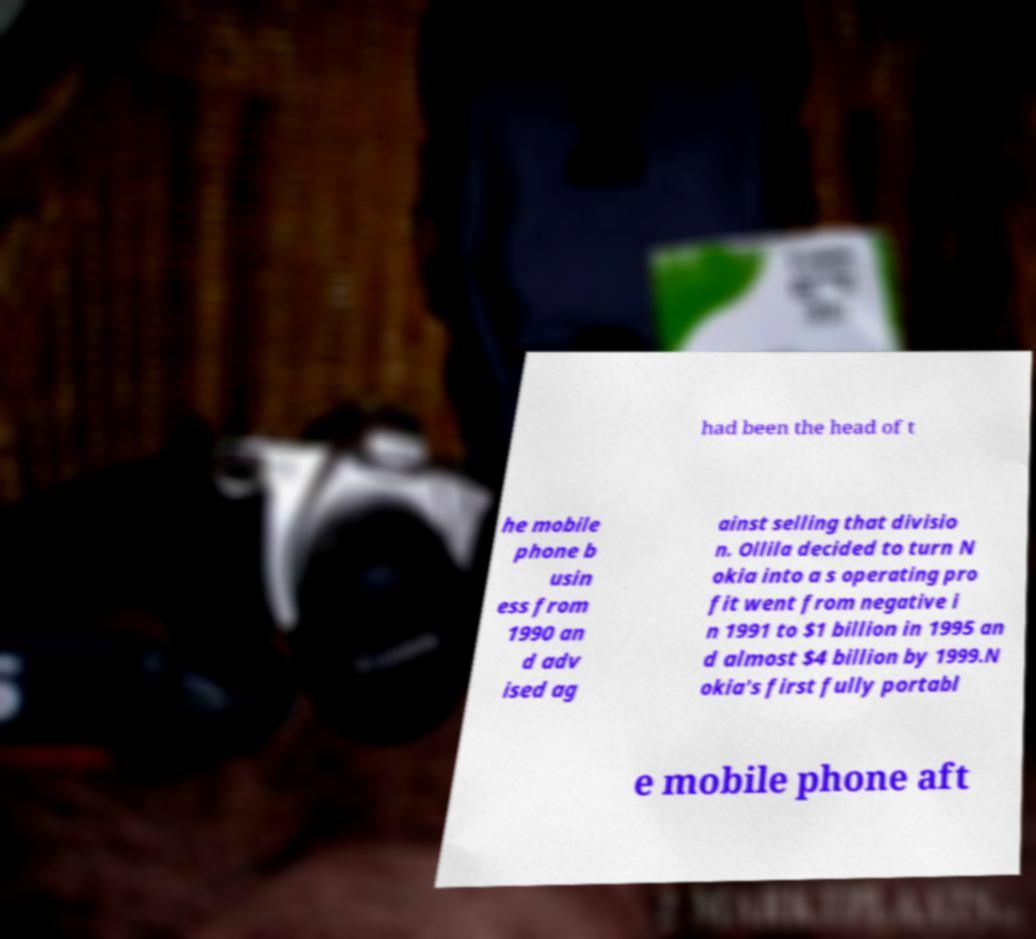For documentation purposes, I need the text within this image transcribed. Could you provide that? had been the head of t he mobile phone b usin ess from 1990 an d adv ised ag ainst selling that divisio n. Ollila decided to turn N okia into a s operating pro fit went from negative i n 1991 to $1 billion in 1995 an d almost $4 billion by 1999.N okia's first fully portabl e mobile phone aft 